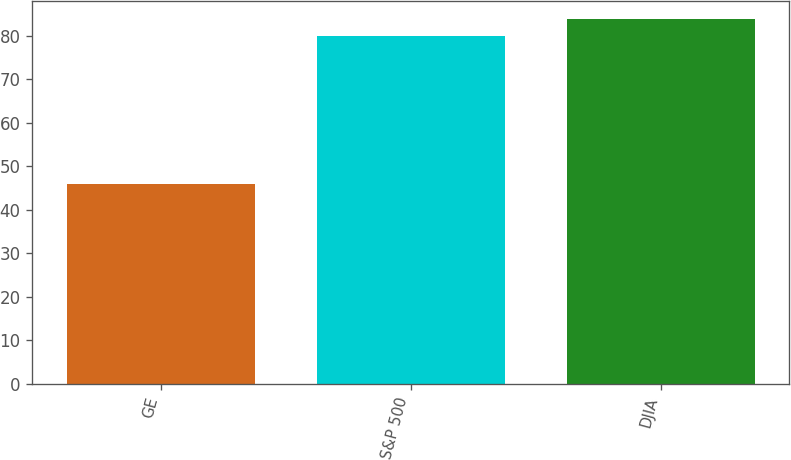Convert chart. <chart><loc_0><loc_0><loc_500><loc_500><bar_chart><fcel>GE<fcel>S&P 500<fcel>DJIA<nl><fcel>46<fcel>80<fcel>83.7<nl></chart> 